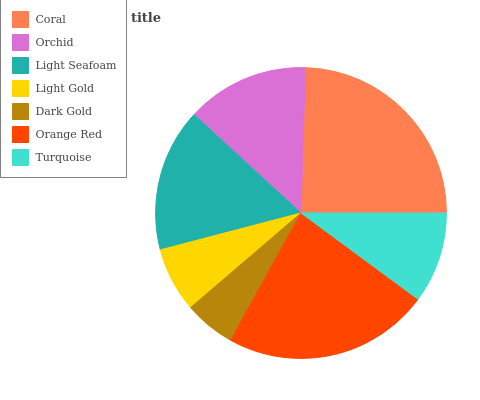Is Dark Gold the minimum?
Answer yes or no. Yes. Is Coral the maximum?
Answer yes or no. Yes. Is Orchid the minimum?
Answer yes or no. No. Is Orchid the maximum?
Answer yes or no. No. Is Coral greater than Orchid?
Answer yes or no. Yes. Is Orchid less than Coral?
Answer yes or no. Yes. Is Orchid greater than Coral?
Answer yes or no. No. Is Coral less than Orchid?
Answer yes or no. No. Is Orchid the high median?
Answer yes or no. Yes. Is Orchid the low median?
Answer yes or no. Yes. Is Dark Gold the high median?
Answer yes or no. No. Is Light Gold the low median?
Answer yes or no. No. 